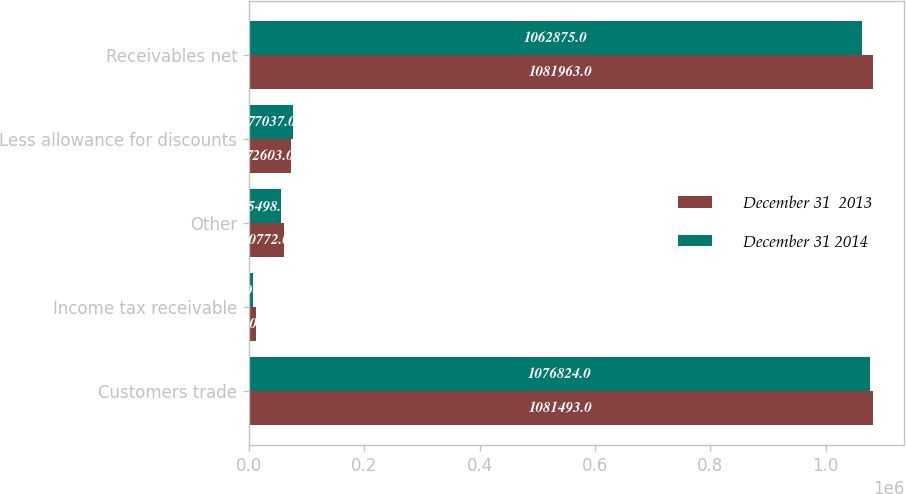<chart> <loc_0><loc_0><loc_500><loc_500><stacked_bar_chart><ecel><fcel>Customers trade<fcel>Income tax receivable<fcel>Other<fcel>Less allowance for discounts<fcel>Receivables net<nl><fcel>December 31  2013<fcel>1.08149e+06<fcel>12301<fcel>60772<fcel>72603<fcel>1.08196e+06<nl><fcel>December 31 2014<fcel>1.07682e+06<fcel>7590<fcel>55498<fcel>77037<fcel>1.06288e+06<nl></chart> 